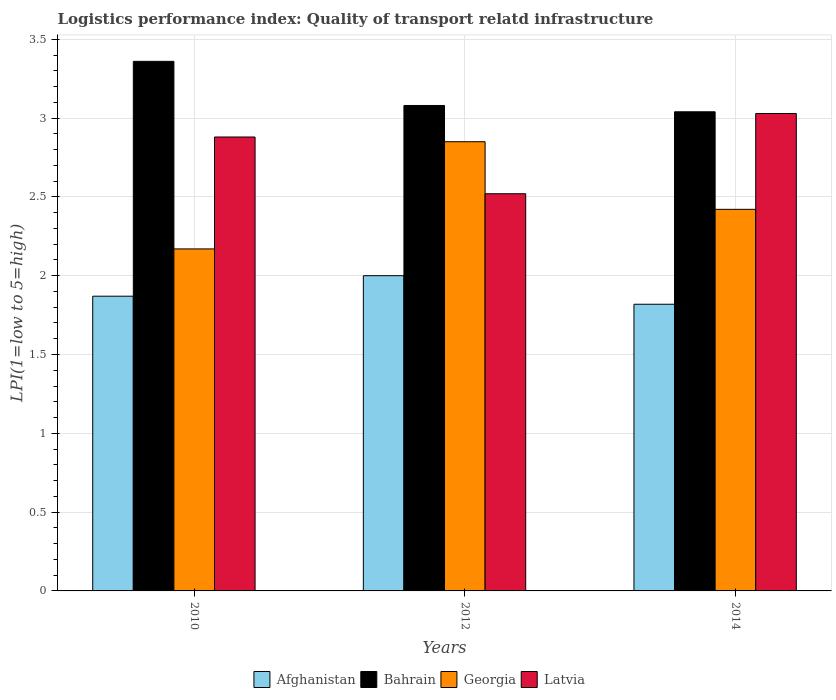How many different coloured bars are there?
Your response must be concise. 4. How many groups of bars are there?
Your answer should be compact. 3. Are the number of bars on each tick of the X-axis equal?
Ensure brevity in your answer.  Yes. In how many cases, is the number of bars for a given year not equal to the number of legend labels?
Give a very brief answer. 0. What is the logistics performance index in Afghanistan in 2010?
Ensure brevity in your answer.  1.87. Across all years, what is the maximum logistics performance index in Latvia?
Offer a very short reply. 3.03. Across all years, what is the minimum logistics performance index in Georgia?
Keep it short and to the point. 2.17. In which year was the logistics performance index in Afghanistan maximum?
Your answer should be very brief. 2012. What is the total logistics performance index in Bahrain in the graph?
Keep it short and to the point. 9.48. What is the difference between the logistics performance index in Georgia in 2012 and that in 2014?
Your answer should be very brief. 0.43. What is the difference between the logistics performance index in Latvia in 2014 and the logistics performance index in Georgia in 2012?
Keep it short and to the point. 0.18. What is the average logistics performance index in Georgia per year?
Your answer should be very brief. 2.48. In the year 2014, what is the difference between the logistics performance index in Latvia and logistics performance index in Bahrain?
Your answer should be very brief. -0.01. What is the ratio of the logistics performance index in Afghanistan in 2010 to that in 2014?
Make the answer very short. 1.03. Is the difference between the logistics performance index in Latvia in 2010 and 2012 greater than the difference between the logistics performance index in Bahrain in 2010 and 2012?
Keep it short and to the point. Yes. What is the difference between the highest and the second highest logistics performance index in Bahrain?
Your answer should be compact. 0.28. What is the difference between the highest and the lowest logistics performance index in Latvia?
Make the answer very short. 0.51. In how many years, is the logistics performance index in Afghanistan greater than the average logistics performance index in Afghanistan taken over all years?
Offer a terse response. 1. Is the sum of the logistics performance index in Georgia in 2012 and 2014 greater than the maximum logistics performance index in Latvia across all years?
Your answer should be very brief. Yes. Is it the case that in every year, the sum of the logistics performance index in Bahrain and logistics performance index in Georgia is greater than the sum of logistics performance index in Latvia and logistics performance index in Afghanistan?
Offer a terse response. No. What does the 3rd bar from the left in 2010 represents?
Make the answer very short. Georgia. What does the 2nd bar from the right in 2012 represents?
Offer a terse response. Georgia. Is it the case that in every year, the sum of the logistics performance index in Latvia and logistics performance index in Bahrain is greater than the logistics performance index in Afghanistan?
Offer a terse response. Yes. How many bars are there?
Give a very brief answer. 12. Does the graph contain any zero values?
Give a very brief answer. No. What is the title of the graph?
Give a very brief answer. Logistics performance index: Quality of transport relatd infrastructure. Does "Liechtenstein" appear as one of the legend labels in the graph?
Make the answer very short. No. What is the label or title of the X-axis?
Provide a short and direct response. Years. What is the label or title of the Y-axis?
Offer a terse response. LPI(1=low to 5=high). What is the LPI(1=low to 5=high) in Afghanistan in 2010?
Ensure brevity in your answer.  1.87. What is the LPI(1=low to 5=high) in Bahrain in 2010?
Your answer should be compact. 3.36. What is the LPI(1=low to 5=high) of Georgia in 2010?
Provide a succinct answer. 2.17. What is the LPI(1=low to 5=high) of Latvia in 2010?
Provide a short and direct response. 2.88. What is the LPI(1=low to 5=high) in Afghanistan in 2012?
Ensure brevity in your answer.  2. What is the LPI(1=low to 5=high) of Bahrain in 2012?
Give a very brief answer. 3.08. What is the LPI(1=low to 5=high) of Georgia in 2012?
Provide a succinct answer. 2.85. What is the LPI(1=low to 5=high) in Latvia in 2012?
Offer a very short reply. 2.52. What is the LPI(1=low to 5=high) in Afghanistan in 2014?
Make the answer very short. 1.82. What is the LPI(1=low to 5=high) of Bahrain in 2014?
Ensure brevity in your answer.  3.04. What is the LPI(1=low to 5=high) in Georgia in 2014?
Offer a terse response. 2.42. What is the LPI(1=low to 5=high) of Latvia in 2014?
Make the answer very short. 3.03. Across all years, what is the maximum LPI(1=low to 5=high) of Afghanistan?
Your answer should be compact. 2. Across all years, what is the maximum LPI(1=low to 5=high) in Bahrain?
Provide a succinct answer. 3.36. Across all years, what is the maximum LPI(1=low to 5=high) in Georgia?
Offer a very short reply. 2.85. Across all years, what is the maximum LPI(1=low to 5=high) of Latvia?
Keep it short and to the point. 3.03. Across all years, what is the minimum LPI(1=low to 5=high) in Afghanistan?
Offer a terse response. 1.82. Across all years, what is the minimum LPI(1=low to 5=high) in Bahrain?
Your answer should be compact. 3.04. Across all years, what is the minimum LPI(1=low to 5=high) in Georgia?
Offer a terse response. 2.17. Across all years, what is the minimum LPI(1=low to 5=high) of Latvia?
Offer a very short reply. 2.52. What is the total LPI(1=low to 5=high) of Afghanistan in the graph?
Your answer should be compact. 5.69. What is the total LPI(1=low to 5=high) of Bahrain in the graph?
Offer a terse response. 9.48. What is the total LPI(1=low to 5=high) of Georgia in the graph?
Keep it short and to the point. 7.44. What is the total LPI(1=low to 5=high) in Latvia in the graph?
Keep it short and to the point. 8.43. What is the difference between the LPI(1=low to 5=high) in Afghanistan in 2010 and that in 2012?
Keep it short and to the point. -0.13. What is the difference between the LPI(1=low to 5=high) in Bahrain in 2010 and that in 2012?
Your response must be concise. 0.28. What is the difference between the LPI(1=low to 5=high) of Georgia in 2010 and that in 2012?
Offer a very short reply. -0.68. What is the difference between the LPI(1=low to 5=high) of Latvia in 2010 and that in 2012?
Provide a succinct answer. 0.36. What is the difference between the LPI(1=low to 5=high) in Afghanistan in 2010 and that in 2014?
Make the answer very short. 0.05. What is the difference between the LPI(1=low to 5=high) in Bahrain in 2010 and that in 2014?
Your response must be concise. 0.32. What is the difference between the LPI(1=low to 5=high) in Georgia in 2010 and that in 2014?
Offer a very short reply. -0.25. What is the difference between the LPI(1=low to 5=high) of Latvia in 2010 and that in 2014?
Your answer should be compact. -0.15. What is the difference between the LPI(1=low to 5=high) of Afghanistan in 2012 and that in 2014?
Make the answer very short. 0.18. What is the difference between the LPI(1=low to 5=high) in Bahrain in 2012 and that in 2014?
Offer a very short reply. 0.04. What is the difference between the LPI(1=low to 5=high) in Georgia in 2012 and that in 2014?
Ensure brevity in your answer.  0.43. What is the difference between the LPI(1=low to 5=high) in Latvia in 2012 and that in 2014?
Make the answer very short. -0.51. What is the difference between the LPI(1=low to 5=high) of Afghanistan in 2010 and the LPI(1=low to 5=high) of Bahrain in 2012?
Ensure brevity in your answer.  -1.21. What is the difference between the LPI(1=low to 5=high) of Afghanistan in 2010 and the LPI(1=low to 5=high) of Georgia in 2012?
Offer a terse response. -0.98. What is the difference between the LPI(1=low to 5=high) in Afghanistan in 2010 and the LPI(1=low to 5=high) in Latvia in 2012?
Your response must be concise. -0.65. What is the difference between the LPI(1=low to 5=high) in Bahrain in 2010 and the LPI(1=low to 5=high) in Georgia in 2012?
Make the answer very short. 0.51. What is the difference between the LPI(1=low to 5=high) in Bahrain in 2010 and the LPI(1=low to 5=high) in Latvia in 2012?
Your response must be concise. 0.84. What is the difference between the LPI(1=low to 5=high) in Georgia in 2010 and the LPI(1=low to 5=high) in Latvia in 2012?
Offer a very short reply. -0.35. What is the difference between the LPI(1=low to 5=high) in Afghanistan in 2010 and the LPI(1=low to 5=high) in Bahrain in 2014?
Your answer should be compact. -1.17. What is the difference between the LPI(1=low to 5=high) in Afghanistan in 2010 and the LPI(1=low to 5=high) in Georgia in 2014?
Give a very brief answer. -0.55. What is the difference between the LPI(1=low to 5=high) of Afghanistan in 2010 and the LPI(1=low to 5=high) of Latvia in 2014?
Your answer should be compact. -1.16. What is the difference between the LPI(1=low to 5=high) of Bahrain in 2010 and the LPI(1=low to 5=high) of Georgia in 2014?
Offer a very short reply. 0.94. What is the difference between the LPI(1=low to 5=high) in Bahrain in 2010 and the LPI(1=low to 5=high) in Latvia in 2014?
Keep it short and to the point. 0.33. What is the difference between the LPI(1=low to 5=high) in Georgia in 2010 and the LPI(1=low to 5=high) in Latvia in 2014?
Offer a very short reply. -0.86. What is the difference between the LPI(1=low to 5=high) in Afghanistan in 2012 and the LPI(1=low to 5=high) in Bahrain in 2014?
Ensure brevity in your answer.  -1.04. What is the difference between the LPI(1=low to 5=high) in Afghanistan in 2012 and the LPI(1=low to 5=high) in Georgia in 2014?
Your answer should be compact. -0.42. What is the difference between the LPI(1=low to 5=high) of Afghanistan in 2012 and the LPI(1=low to 5=high) of Latvia in 2014?
Your response must be concise. -1.03. What is the difference between the LPI(1=low to 5=high) in Bahrain in 2012 and the LPI(1=low to 5=high) in Georgia in 2014?
Provide a short and direct response. 0.66. What is the difference between the LPI(1=low to 5=high) in Bahrain in 2012 and the LPI(1=low to 5=high) in Latvia in 2014?
Your response must be concise. 0.05. What is the difference between the LPI(1=low to 5=high) in Georgia in 2012 and the LPI(1=low to 5=high) in Latvia in 2014?
Give a very brief answer. -0.18. What is the average LPI(1=low to 5=high) in Afghanistan per year?
Give a very brief answer. 1.9. What is the average LPI(1=low to 5=high) of Bahrain per year?
Offer a terse response. 3.16. What is the average LPI(1=low to 5=high) of Georgia per year?
Your answer should be very brief. 2.48. What is the average LPI(1=low to 5=high) in Latvia per year?
Your answer should be very brief. 2.81. In the year 2010, what is the difference between the LPI(1=low to 5=high) in Afghanistan and LPI(1=low to 5=high) in Bahrain?
Offer a very short reply. -1.49. In the year 2010, what is the difference between the LPI(1=low to 5=high) of Afghanistan and LPI(1=low to 5=high) of Georgia?
Your response must be concise. -0.3. In the year 2010, what is the difference between the LPI(1=low to 5=high) in Afghanistan and LPI(1=low to 5=high) in Latvia?
Make the answer very short. -1.01. In the year 2010, what is the difference between the LPI(1=low to 5=high) of Bahrain and LPI(1=low to 5=high) of Georgia?
Your response must be concise. 1.19. In the year 2010, what is the difference between the LPI(1=low to 5=high) of Bahrain and LPI(1=low to 5=high) of Latvia?
Your answer should be very brief. 0.48. In the year 2010, what is the difference between the LPI(1=low to 5=high) in Georgia and LPI(1=low to 5=high) in Latvia?
Provide a succinct answer. -0.71. In the year 2012, what is the difference between the LPI(1=low to 5=high) of Afghanistan and LPI(1=low to 5=high) of Bahrain?
Ensure brevity in your answer.  -1.08. In the year 2012, what is the difference between the LPI(1=low to 5=high) in Afghanistan and LPI(1=low to 5=high) in Georgia?
Give a very brief answer. -0.85. In the year 2012, what is the difference between the LPI(1=low to 5=high) of Afghanistan and LPI(1=low to 5=high) of Latvia?
Offer a terse response. -0.52. In the year 2012, what is the difference between the LPI(1=low to 5=high) of Bahrain and LPI(1=low to 5=high) of Georgia?
Your response must be concise. 0.23. In the year 2012, what is the difference between the LPI(1=low to 5=high) of Bahrain and LPI(1=low to 5=high) of Latvia?
Ensure brevity in your answer.  0.56. In the year 2012, what is the difference between the LPI(1=low to 5=high) in Georgia and LPI(1=low to 5=high) in Latvia?
Your response must be concise. 0.33. In the year 2014, what is the difference between the LPI(1=low to 5=high) of Afghanistan and LPI(1=low to 5=high) of Bahrain?
Provide a short and direct response. -1.22. In the year 2014, what is the difference between the LPI(1=low to 5=high) in Afghanistan and LPI(1=low to 5=high) in Georgia?
Your answer should be compact. -0.6. In the year 2014, what is the difference between the LPI(1=low to 5=high) in Afghanistan and LPI(1=low to 5=high) in Latvia?
Provide a succinct answer. -1.21. In the year 2014, what is the difference between the LPI(1=low to 5=high) of Bahrain and LPI(1=low to 5=high) of Georgia?
Offer a terse response. 0.62. In the year 2014, what is the difference between the LPI(1=low to 5=high) in Bahrain and LPI(1=low to 5=high) in Latvia?
Keep it short and to the point. 0.01. In the year 2014, what is the difference between the LPI(1=low to 5=high) in Georgia and LPI(1=low to 5=high) in Latvia?
Your response must be concise. -0.61. What is the ratio of the LPI(1=low to 5=high) of Afghanistan in 2010 to that in 2012?
Make the answer very short. 0.94. What is the ratio of the LPI(1=low to 5=high) in Bahrain in 2010 to that in 2012?
Keep it short and to the point. 1.09. What is the ratio of the LPI(1=low to 5=high) in Georgia in 2010 to that in 2012?
Your answer should be compact. 0.76. What is the ratio of the LPI(1=low to 5=high) in Afghanistan in 2010 to that in 2014?
Make the answer very short. 1.03. What is the ratio of the LPI(1=low to 5=high) of Bahrain in 2010 to that in 2014?
Offer a very short reply. 1.11. What is the ratio of the LPI(1=low to 5=high) of Georgia in 2010 to that in 2014?
Your answer should be compact. 0.9. What is the ratio of the LPI(1=low to 5=high) in Latvia in 2010 to that in 2014?
Offer a very short reply. 0.95. What is the ratio of the LPI(1=low to 5=high) in Afghanistan in 2012 to that in 2014?
Make the answer very short. 1.1. What is the ratio of the LPI(1=low to 5=high) of Bahrain in 2012 to that in 2014?
Make the answer very short. 1.01. What is the ratio of the LPI(1=low to 5=high) in Georgia in 2012 to that in 2014?
Your answer should be very brief. 1.18. What is the ratio of the LPI(1=low to 5=high) in Latvia in 2012 to that in 2014?
Offer a very short reply. 0.83. What is the difference between the highest and the second highest LPI(1=low to 5=high) of Afghanistan?
Give a very brief answer. 0.13. What is the difference between the highest and the second highest LPI(1=low to 5=high) of Bahrain?
Ensure brevity in your answer.  0.28. What is the difference between the highest and the second highest LPI(1=low to 5=high) of Georgia?
Your answer should be very brief. 0.43. What is the difference between the highest and the second highest LPI(1=low to 5=high) of Latvia?
Your answer should be compact. 0.15. What is the difference between the highest and the lowest LPI(1=low to 5=high) of Afghanistan?
Your answer should be very brief. 0.18. What is the difference between the highest and the lowest LPI(1=low to 5=high) in Bahrain?
Provide a short and direct response. 0.32. What is the difference between the highest and the lowest LPI(1=low to 5=high) in Georgia?
Offer a terse response. 0.68. What is the difference between the highest and the lowest LPI(1=low to 5=high) of Latvia?
Offer a terse response. 0.51. 